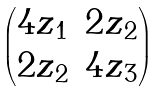<formula> <loc_0><loc_0><loc_500><loc_500>\begin{pmatrix} 4 z _ { 1 } & 2 z _ { 2 } \\ 2 z _ { 2 } & 4 z _ { 3 } \end{pmatrix}</formula> 